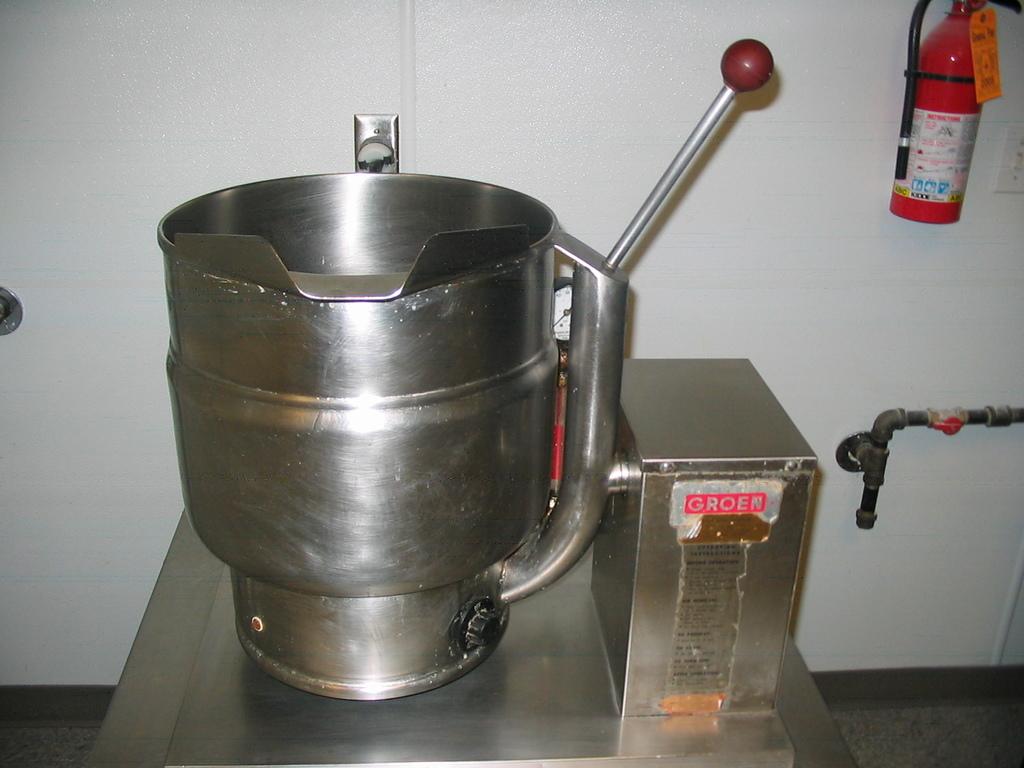What is the company name on the machine?
Your answer should be compact. Groen. 